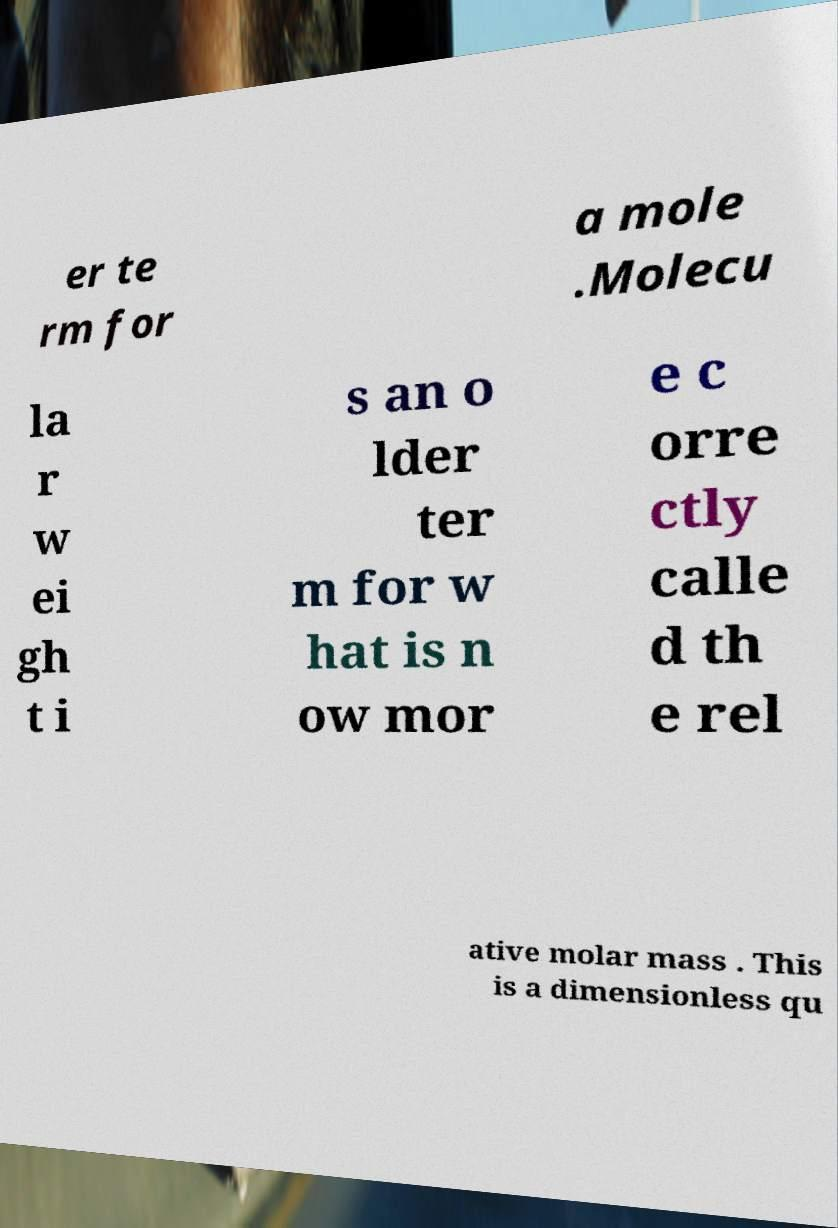What messages or text are displayed in this image? I need them in a readable, typed format. er te rm for a mole .Molecu la r w ei gh t i s an o lder ter m for w hat is n ow mor e c orre ctly calle d th e rel ative molar mass . This is a dimensionless qu 